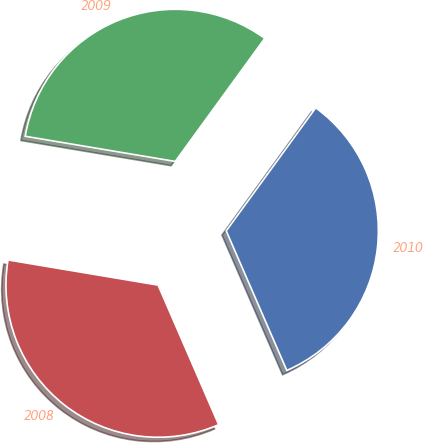Convert chart to OTSL. <chart><loc_0><loc_0><loc_500><loc_500><pie_chart><fcel>2010<fcel>2009<fcel>2008<nl><fcel>33.47%<fcel>32.36%<fcel>34.16%<nl></chart> 